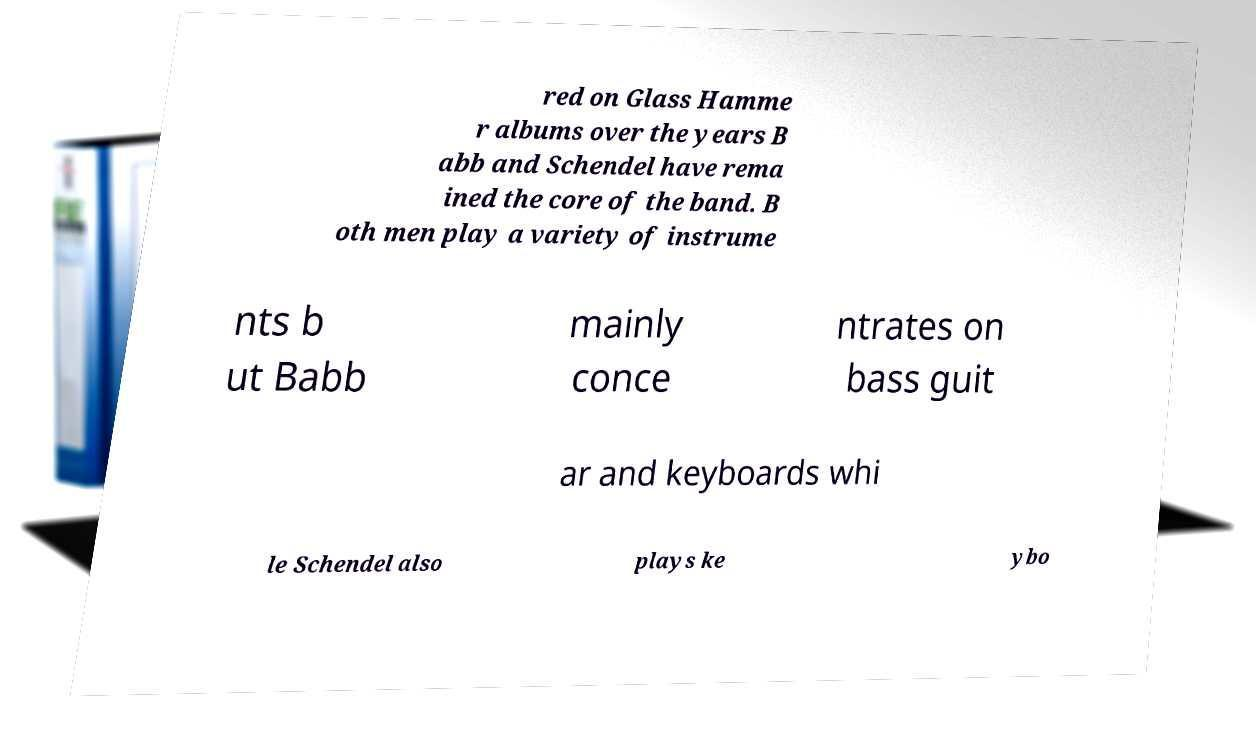Can you read and provide the text displayed in the image?This photo seems to have some interesting text. Can you extract and type it out for me? red on Glass Hamme r albums over the years B abb and Schendel have rema ined the core of the band. B oth men play a variety of instrume nts b ut Babb mainly conce ntrates on bass guit ar and keyboards whi le Schendel also plays ke ybo 